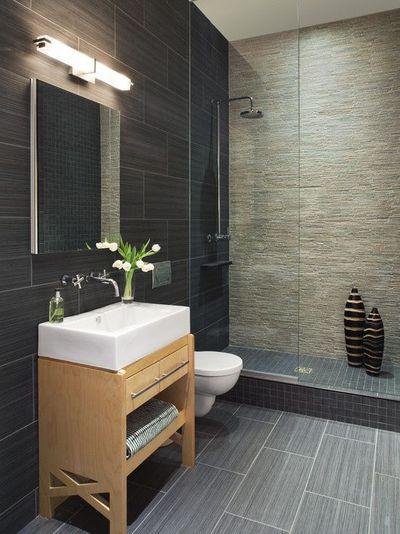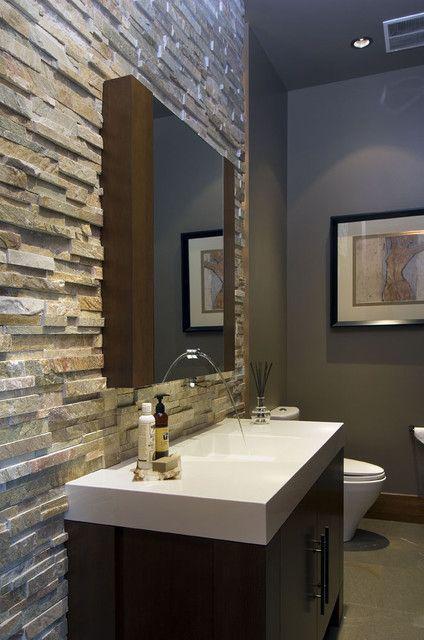The first image is the image on the left, the second image is the image on the right. Analyze the images presented: Is the assertion "One of the images contains a soft bath mat on the floor." valid? Answer yes or no. No. The first image is the image on the left, the second image is the image on the right. Evaluate the accuracy of this statement regarding the images: "One image features a bathtub, and the other shows a vessel sink atop a counter with an open space and shelf beneath it.". Is it true? Answer yes or no. No. 